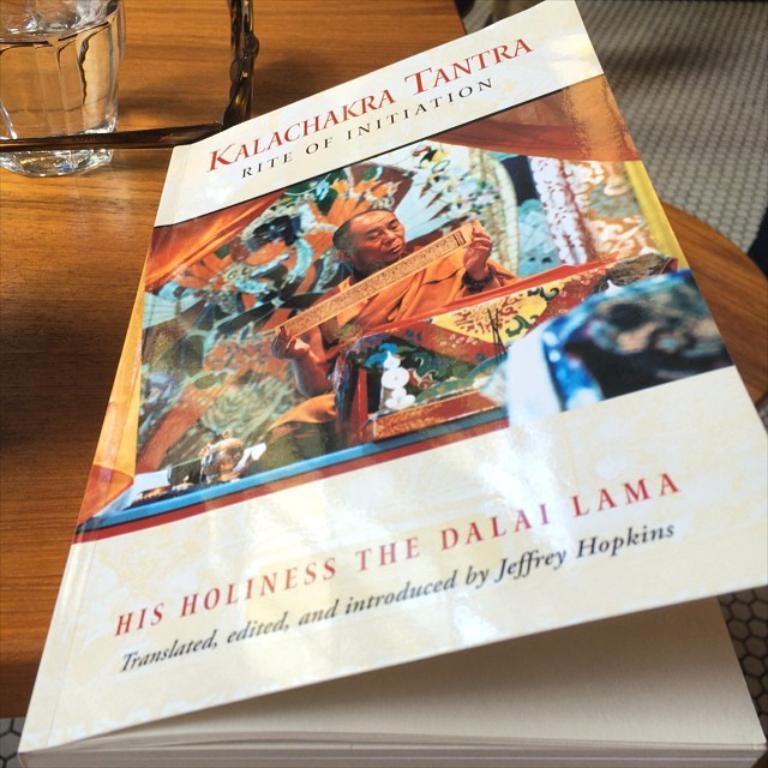What is the title of this book?
Ensure brevity in your answer.  Kalachakra tantra. 